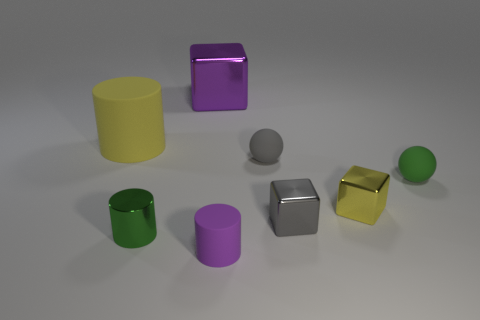There is a metallic cube that is behind the green object on the right side of the purple matte cylinder; what color is it?
Your response must be concise. Purple. Are there more tiny yellow metallic cylinders than spheres?
Make the answer very short. No. What number of gray metallic blocks are the same size as the yellow shiny object?
Your answer should be compact. 1. Do the tiny green cylinder and the gray thing on the left side of the tiny gray metal thing have the same material?
Your answer should be very brief. No. Are there fewer gray rubber spheres than big green metallic cylinders?
Keep it short and to the point. No. Is there any other thing of the same color as the big cylinder?
Offer a terse response. Yes. There is a large object that is made of the same material as the gray block; what shape is it?
Your answer should be compact. Cube. How many tiny green objects are to the left of the yellow object in front of the green object that is right of the purple matte object?
Give a very brief answer. 1. There is a rubber object that is both behind the green matte thing and to the right of the big rubber thing; what shape is it?
Offer a terse response. Sphere. Is the number of shiny cubes left of the large yellow rubber thing less than the number of large blue cubes?
Your response must be concise. No. 